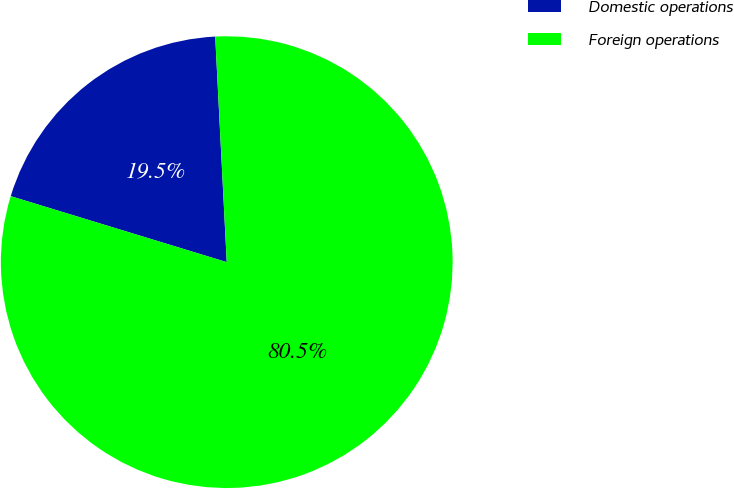Convert chart. <chart><loc_0><loc_0><loc_500><loc_500><pie_chart><fcel>Domestic operations<fcel>Foreign operations<nl><fcel>19.47%<fcel>80.53%<nl></chart> 